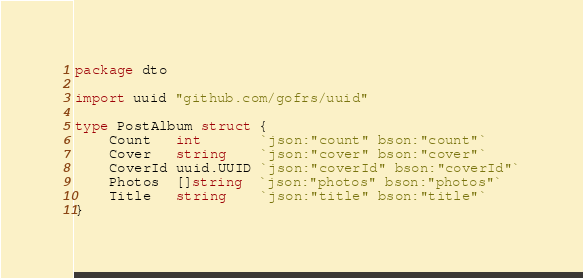<code> <loc_0><loc_0><loc_500><loc_500><_Go_>package dto

import uuid "github.com/gofrs/uuid"

type PostAlbum struct {
	Count   int       `json:"count" bson:"count"`
	Cover   string    `json:"cover" bson:"cover"`
	CoverId uuid.UUID `json:"coverId" bson:"coverId"`
	Photos  []string  `json:"photos" bson:"photos"`
	Title   string    `json:"title" bson:"title"`
}
</code> 